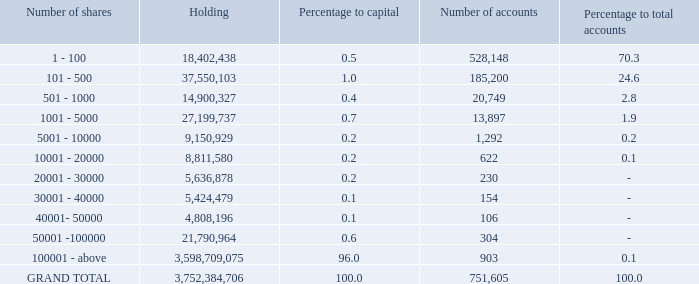Xii. shareholding as on march 31, 2019:
a. distribution of equity shareholding as on march 31, 2019:
what is the number of existing shareholding accounts as on march 31, 2019?   751,605. Which category of number of shares has the highest number of accounts? 1 - 100. How many accounts hold 100001 and above number of shares? 903. What is the percentage of accounts holding 20001 - 100000 number of shares?
Answer scale should be: percent. (230+154+106+304)/751,605 
Answer: 0.11. Excluding shareholding of 100001 shares and above, what is the percentage to capital of the rest? 
Answer scale should be: percent. 100-96 
Answer: 4. How many accounts hold 1000 or lesser number of shares? 528,148+185,200+20,749 
Answer: 734097. 